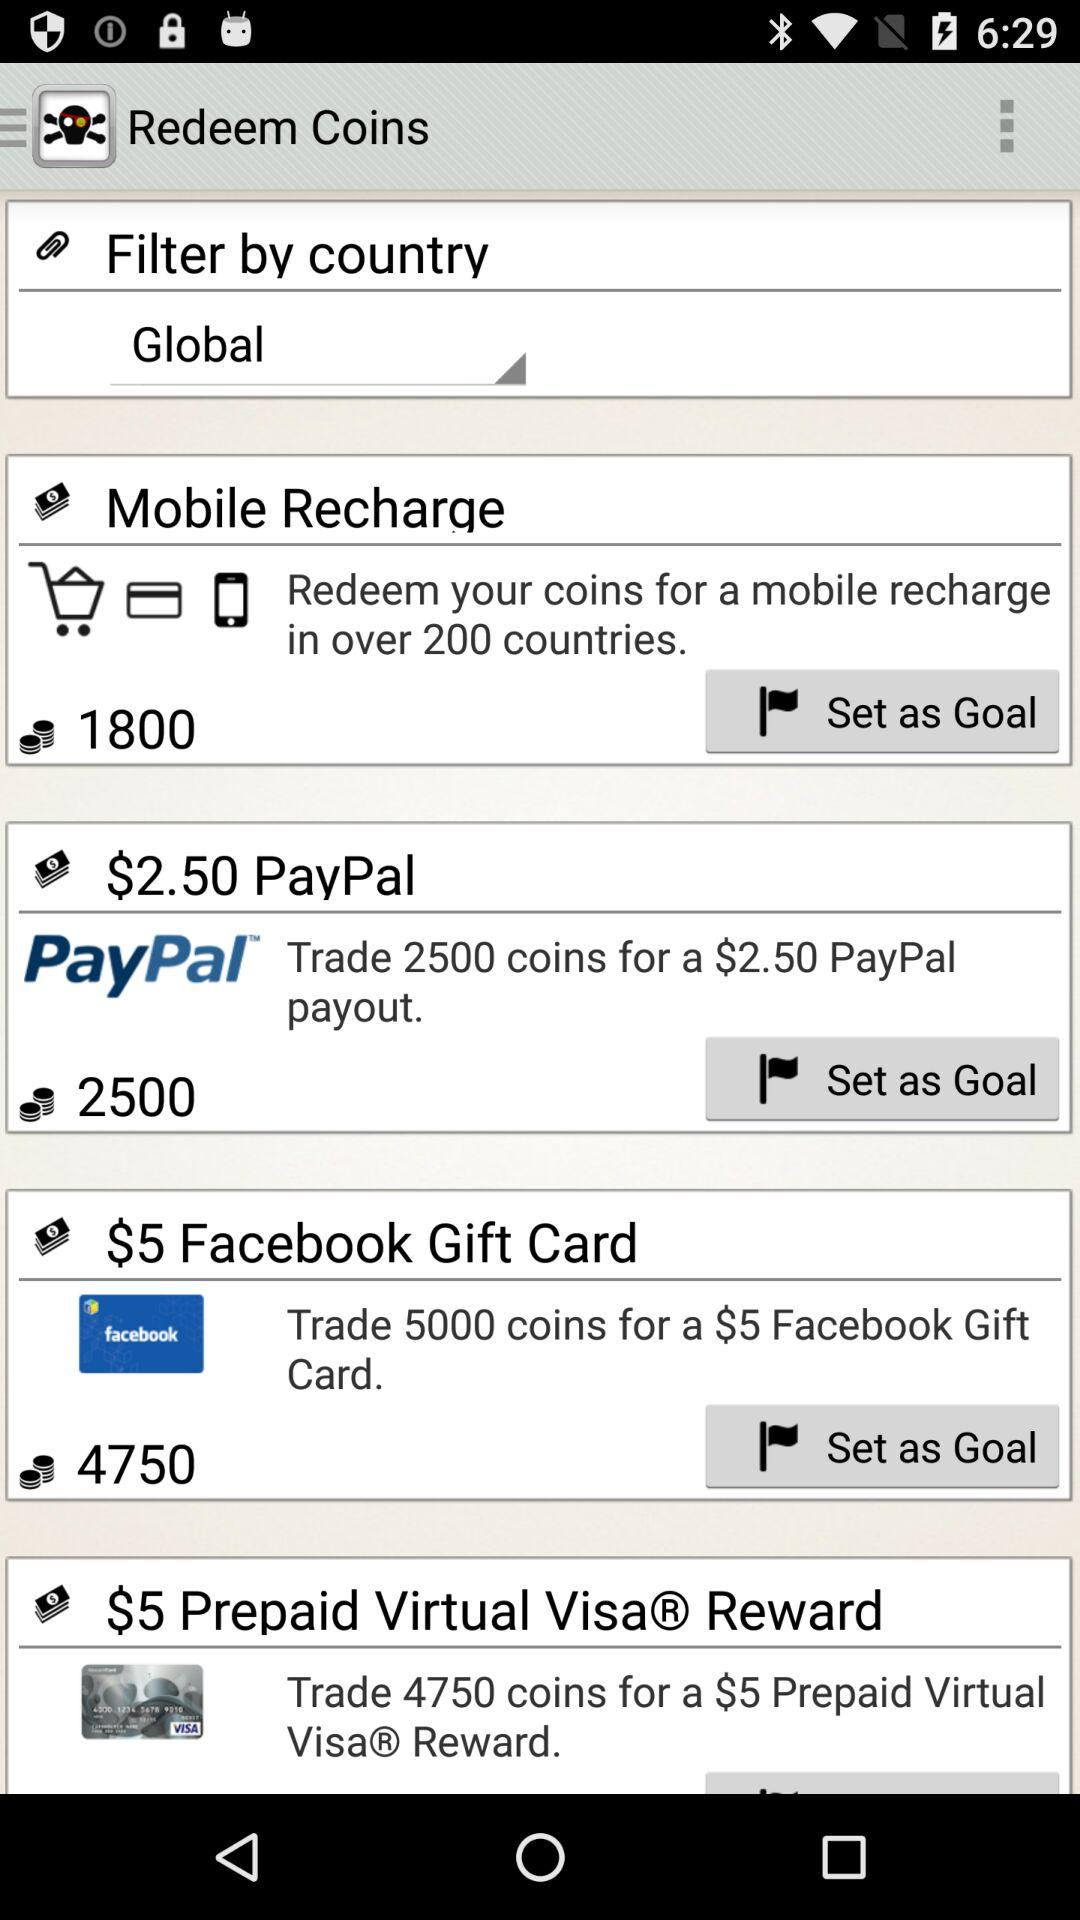What is the maximum number of coins we may trade for a $5 "Prepaid Virtual Visa® Reward"? The maximum number of coins is 4750. 